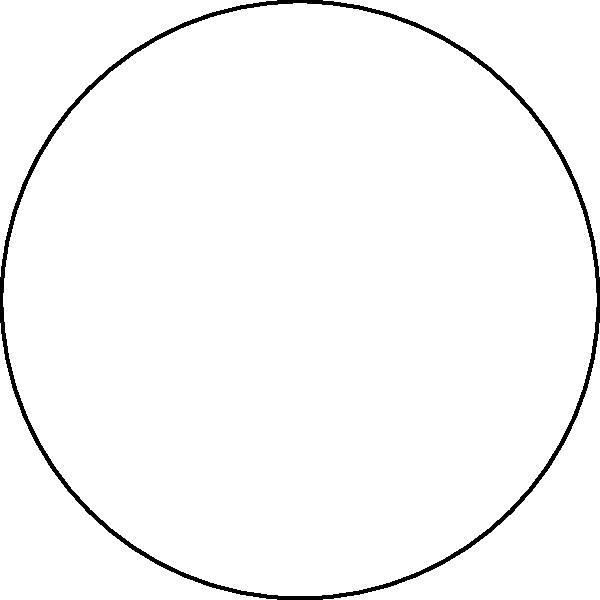A circular watercolor palette has a radius of 10 cm and contains 6 equally spaced circular color wells along its perimeter. Each color well has a radius of 2 cm. What percentage of the palette's total area is not occupied by the color wells? Let's approach this step-by-step:

1) Area of the main palette:
   $A_{palette} = \pi R^2 = \pi (10 \text{ cm})^2 = 100\pi \text{ cm}^2$

2) Area of each color well:
   $A_{well} = \pi r^2 = \pi (2 \text{ cm})^2 = 4\pi \text{ cm}^2$

3) Total area of all 6 color wells:
   $A_{total wells} = 6 \times 4\pi \text{ cm}^2 = 24\pi \text{ cm}^2$

4) Area not occupied by color wells:
   $A_{not occupied} = A_{palette} - A_{total wells} = 100\pi \text{ cm}^2 - 24\pi \text{ cm}^2 = 76\pi \text{ cm}^2$

5) Percentage of area not occupied:
   $\text{Percentage} = \frac{A_{not occupied}}{A_{palette}} \times 100\% = \frac{76\pi}{100\pi} \times 100\% = 76\%$

Therefore, 76% of the palette's total area is not occupied by the color wells.
Answer: 76% 